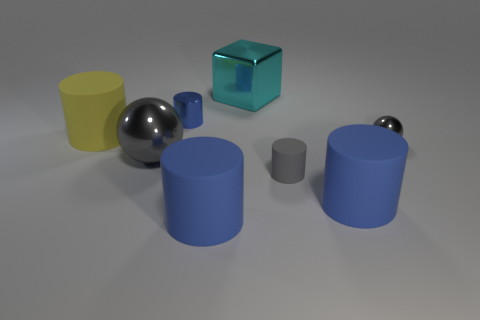Subtract all brown spheres. How many blue cylinders are left? 3 Subtract all yellow cylinders. How many cylinders are left? 4 Subtract all small gray cylinders. How many cylinders are left? 4 Subtract all purple cylinders. Subtract all blue spheres. How many cylinders are left? 5 Add 1 large gray shiny spheres. How many objects exist? 9 Subtract all spheres. How many objects are left? 6 Add 3 blue cylinders. How many blue cylinders are left? 6 Add 5 big yellow cubes. How many big yellow cubes exist? 5 Subtract 0 green cylinders. How many objects are left? 8 Subtract all yellow matte things. Subtract all small gray metal things. How many objects are left? 6 